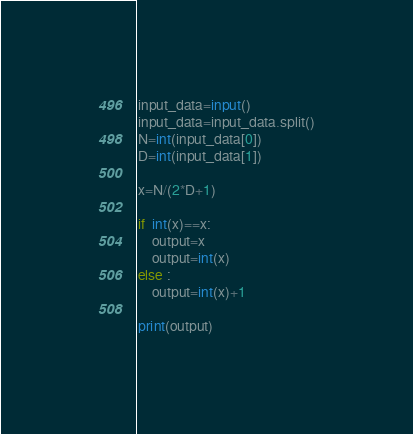<code> <loc_0><loc_0><loc_500><loc_500><_Python_>input_data=input()
input_data=input_data.split()
N=int(input_data[0])
D=int(input_data[1])

x=N/(2*D+1)

if  int(x)==x:
    output=x
    output=int(x)
else :
    output=int(x)+1

print(output)</code> 